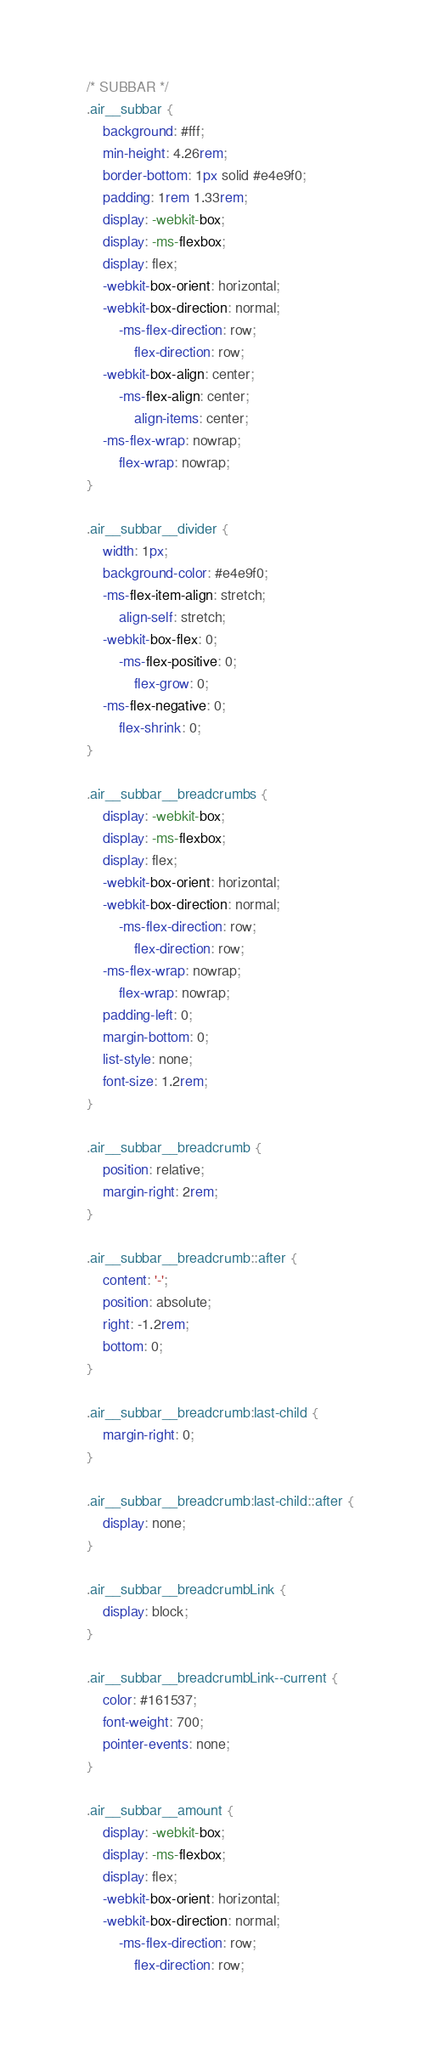Convert code to text. <code><loc_0><loc_0><loc_500><loc_500><_CSS_>/* SUBBAR */
.air__subbar {
    background: #fff;
    min-height: 4.26rem;
    border-bottom: 1px solid #e4e9f0;
    padding: 1rem 1.33rem;
    display: -webkit-box;
    display: -ms-flexbox;
    display: flex;
    -webkit-box-orient: horizontal;
    -webkit-box-direction: normal;
        -ms-flex-direction: row;
            flex-direction: row;
    -webkit-box-align: center;
        -ms-flex-align: center;
            align-items: center;
    -ms-flex-wrap: nowrap;
        flex-wrap: nowrap;
}

.air__subbar__divider {
    width: 1px;
    background-color: #e4e9f0;
    -ms-flex-item-align: stretch;
        align-self: stretch;
    -webkit-box-flex: 0;
        -ms-flex-positive: 0;
            flex-grow: 0;
    -ms-flex-negative: 0;
        flex-shrink: 0;
}

.air__subbar__breadcrumbs {
    display: -webkit-box;
    display: -ms-flexbox;
    display: flex;
    -webkit-box-orient: horizontal;
    -webkit-box-direction: normal;
        -ms-flex-direction: row;
            flex-direction: row;
    -ms-flex-wrap: nowrap;
        flex-wrap: nowrap;
    padding-left: 0;
    margin-bottom: 0;
    list-style: none;
    font-size: 1.2rem;
}

.air__subbar__breadcrumb {
    position: relative;
    margin-right: 2rem;
}

.air__subbar__breadcrumb::after {
    content: '-';
    position: absolute;
    right: -1.2rem;
    bottom: 0;
}

.air__subbar__breadcrumb:last-child {
    margin-right: 0;
}

.air__subbar__breadcrumb:last-child::after {
    display: none;
}

.air__subbar__breadcrumbLink {
    display: block;
}

.air__subbar__breadcrumbLink--current {
    color: #161537;
    font-weight: 700;
    pointer-events: none;
}

.air__subbar__amount {
    display: -webkit-box;
    display: -ms-flexbox;
    display: flex;
    -webkit-box-orient: horizontal;
    -webkit-box-direction: normal;
        -ms-flex-direction: row;
            flex-direction: row;</code> 